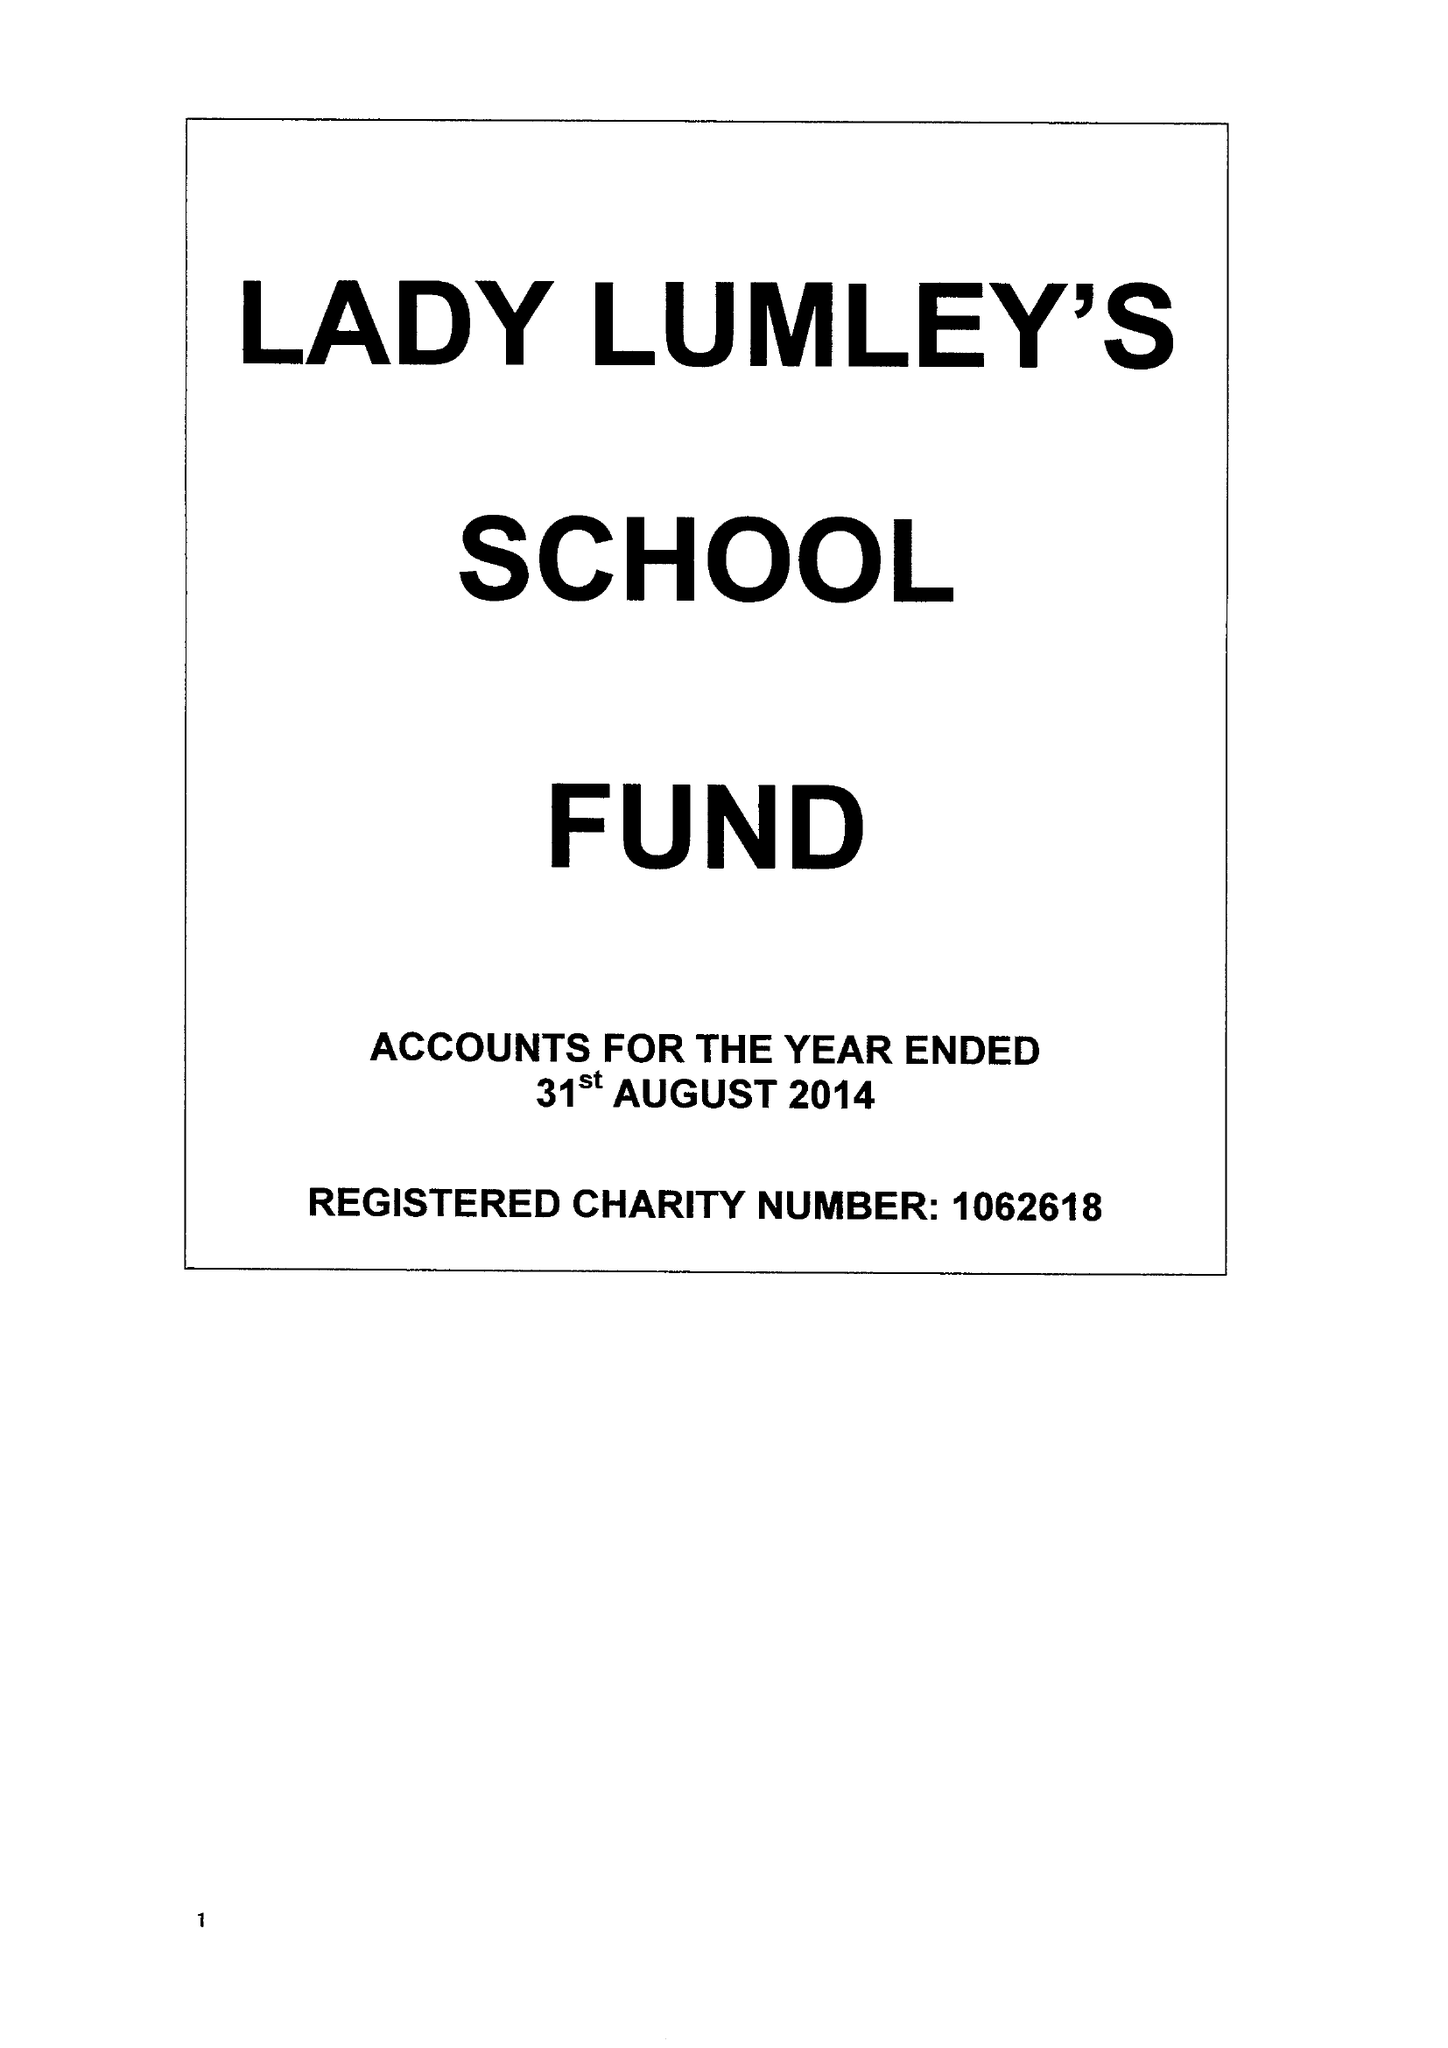What is the value for the income_annually_in_british_pounds?
Answer the question using a single word or phrase. 151549.00 